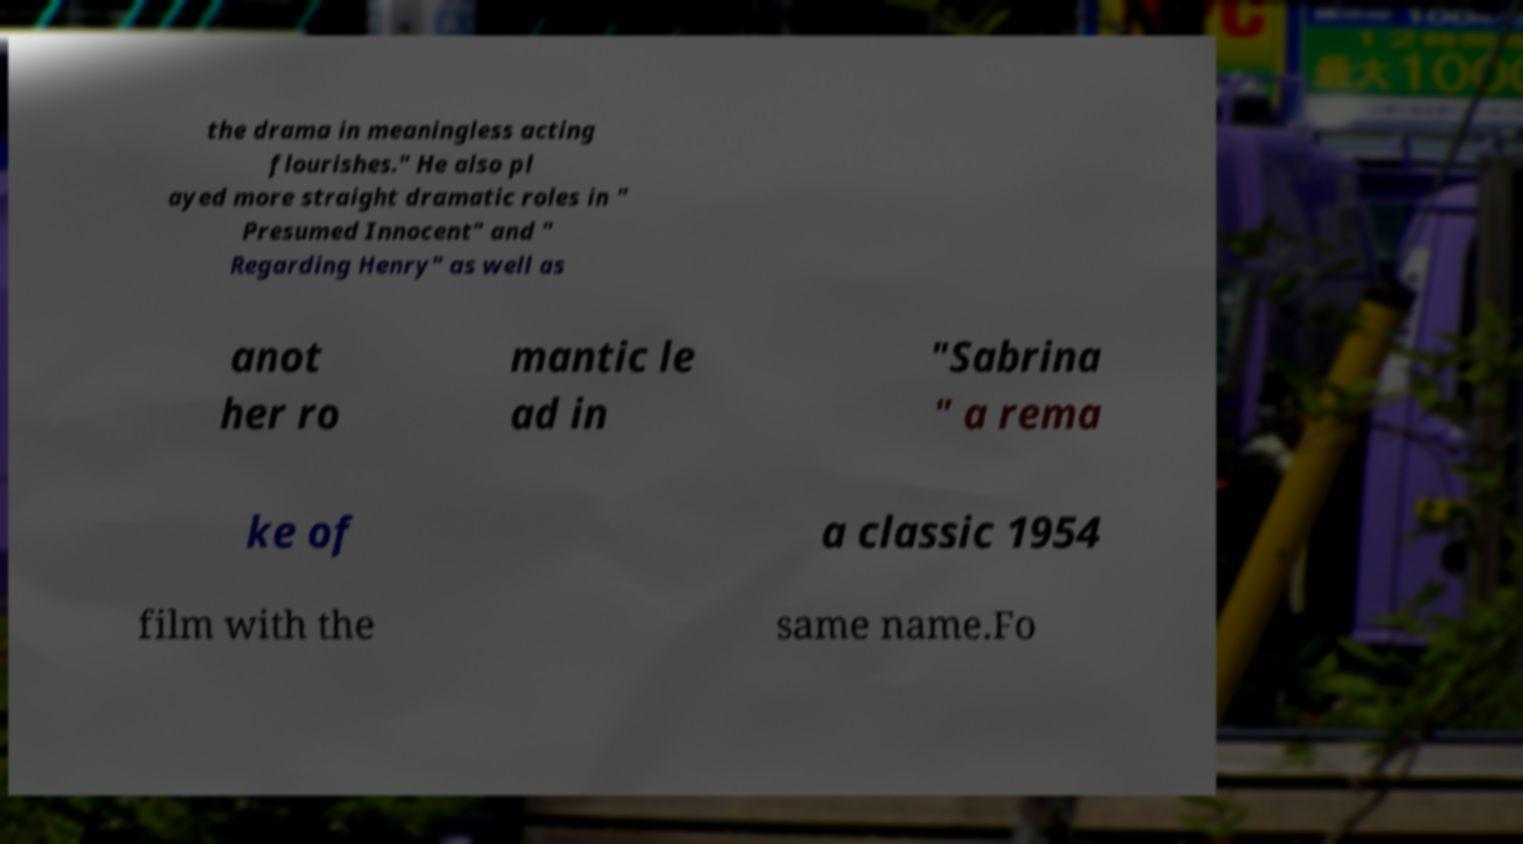There's text embedded in this image that I need extracted. Can you transcribe it verbatim? the drama in meaningless acting flourishes." He also pl ayed more straight dramatic roles in " Presumed Innocent" and " Regarding Henry" as well as anot her ro mantic le ad in "Sabrina " a rema ke of a classic 1954 film with the same name.Fo 